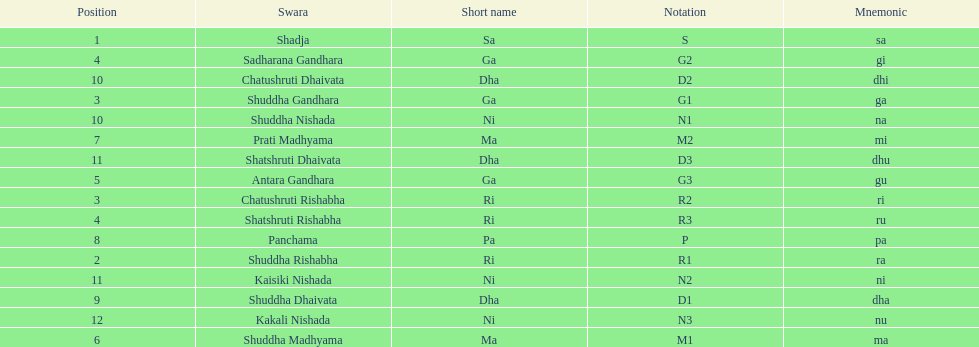What is the total number of positions listed? 16. 